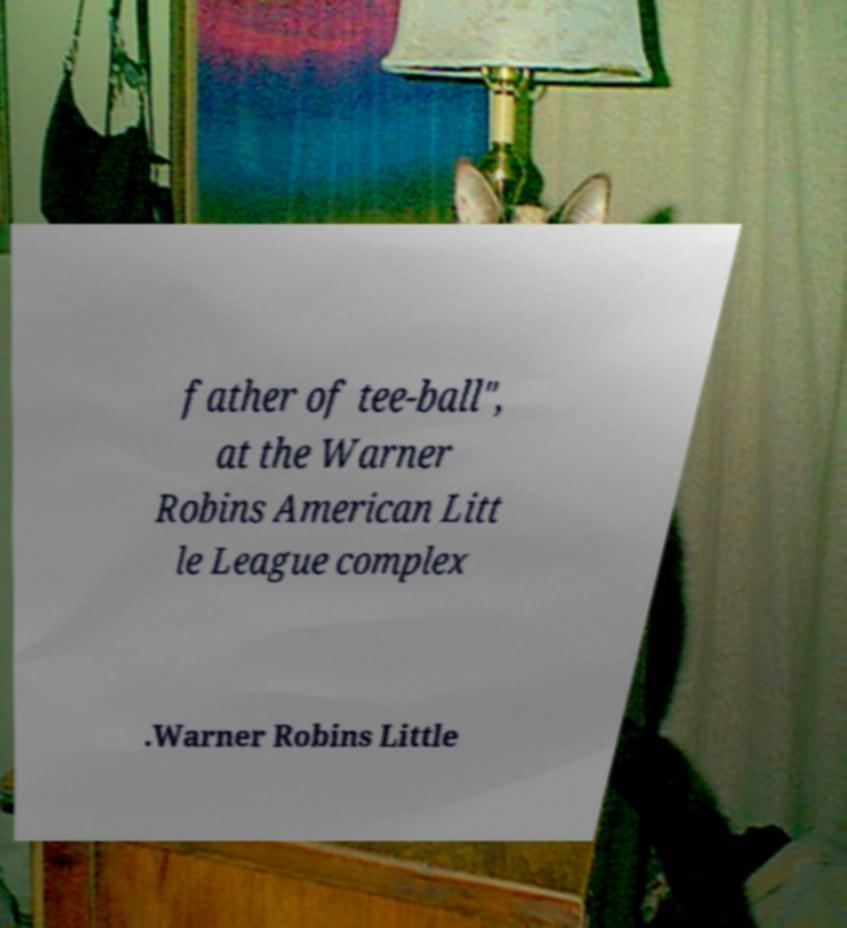What messages or text are displayed in this image? I need them in a readable, typed format. father of tee-ball", at the Warner Robins American Litt le League complex .Warner Robins Little 